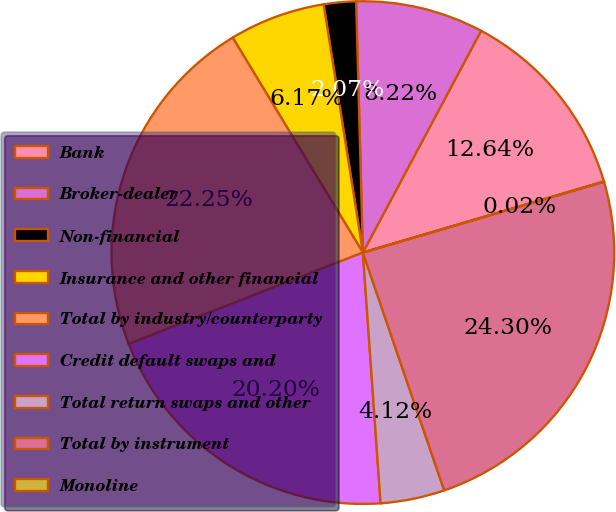Convert chart to OTSL. <chart><loc_0><loc_0><loc_500><loc_500><pie_chart><fcel>Bank<fcel>Broker-dealer<fcel>Non-financial<fcel>Insurance and other financial<fcel>Total by industry/counterparty<fcel>Credit default swaps and<fcel>Total return swaps and other<fcel>Total by instrument<fcel>Monoline<nl><fcel>12.64%<fcel>8.22%<fcel>2.07%<fcel>6.17%<fcel>22.25%<fcel>20.2%<fcel>4.12%<fcel>24.3%<fcel>0.02%<nl></chart> 